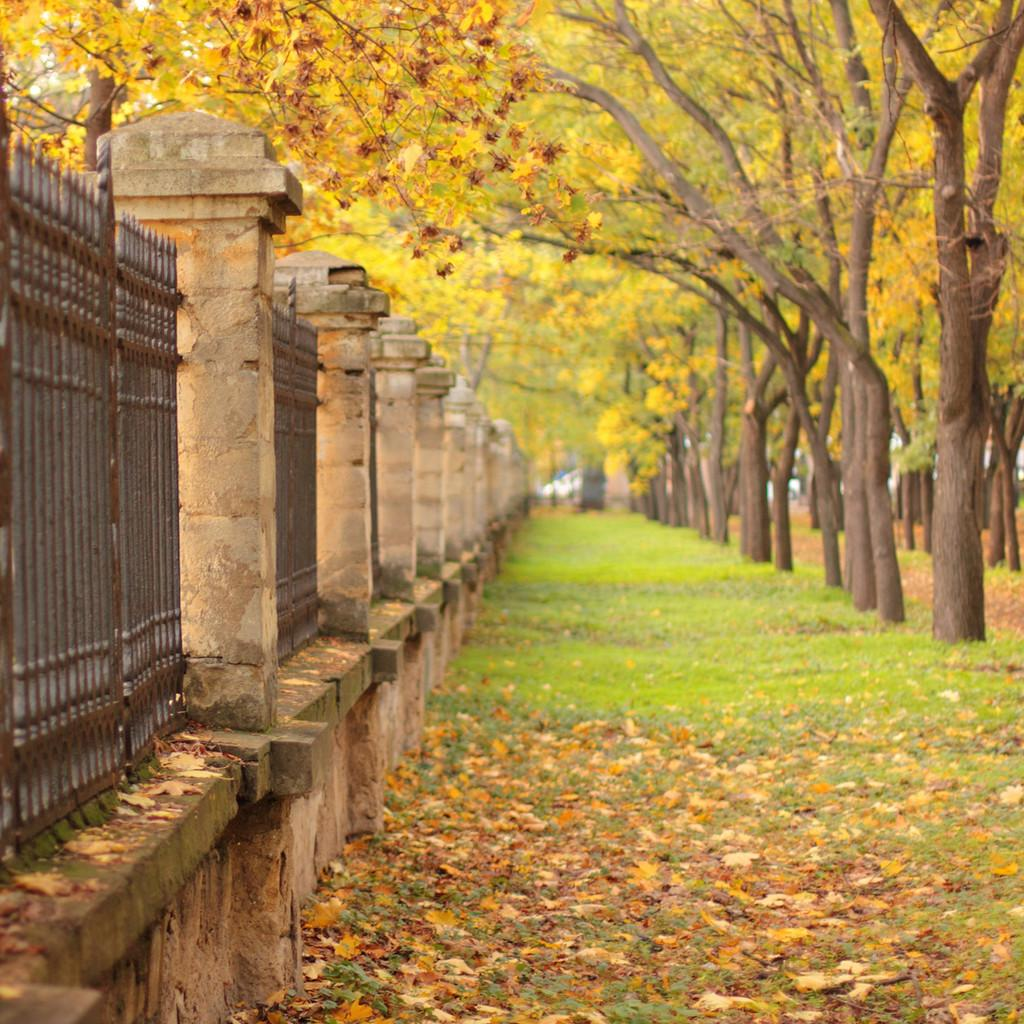What type of structure can be seen in the image? There is fencing in the image. What is located on the left side of the image? There is a wall on the left side of the image. What type of vegetation is visible on the ground? Grass and leaves are visible on the ground. What can be seen on the right side of the image? There are trees on the right side of the image. What type of story is being told by the judge in the image? There is no judge or story present in the image; it features fencing, a wall, grass, leaves, and trees. How does the rainstorm affect the fencing in the image? There is no rainstorm present in the image, so its effect on the fencing cannot be determined. 